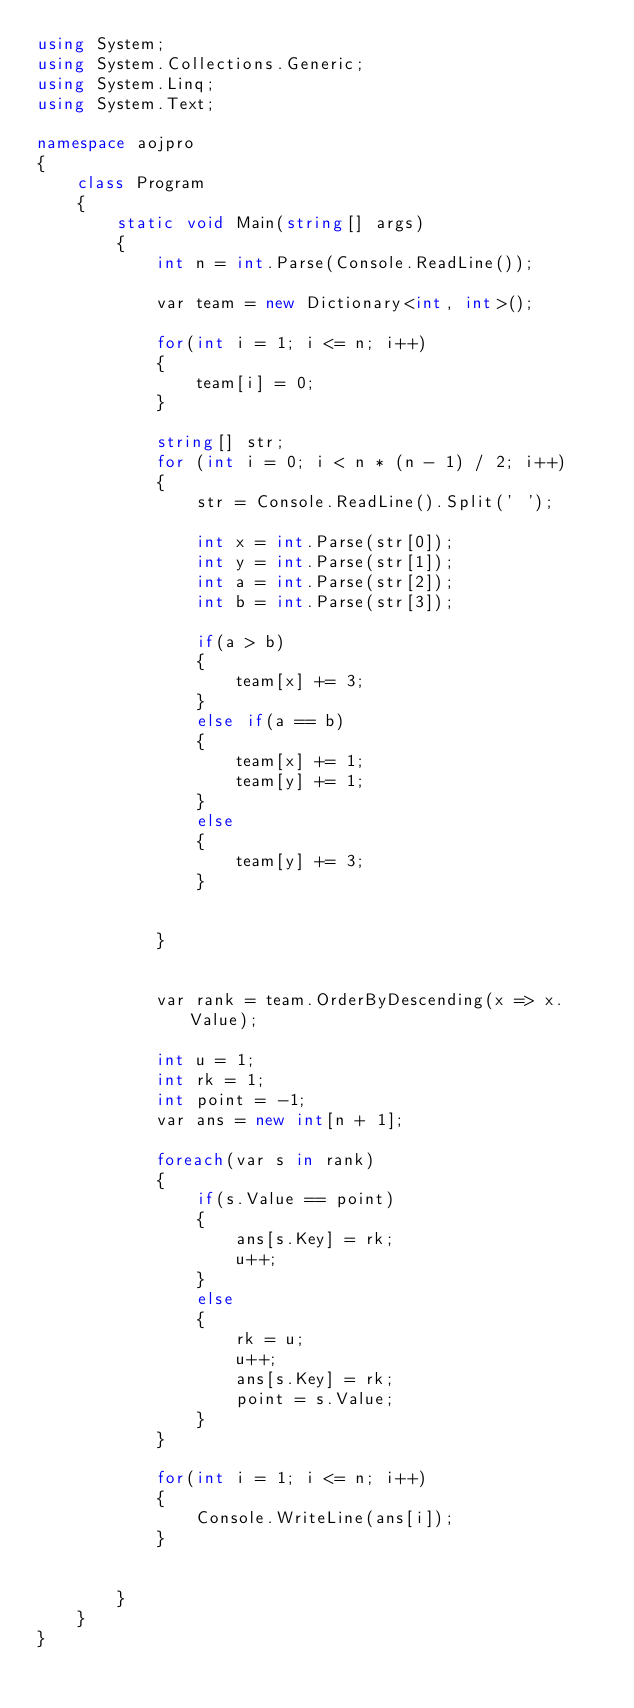Convert code to text. <code><loc_0><loc_0><loc_500><loc_500><_C#_>using System;
using System.Collections.Generic;
using System.Linq;
using System.Text;

namespace aojpro
{
    class Program
    {
        static void Main(string[] args)
        {
            int n = int.Parse(Console.ReadLine());

            var team = new Dictionary<int, int>();

            for(int i = 1; i <= n; i++)
            {
                team[i] = 0;
            }

            string[] str;
            for (int i = 0; i < n * (n - 1) / 2; i++)
            {
                str = Console.ReadLine().Split(' ');

                int x = int.Parse(str[0]);
                int y = int.Parse(str[1]);
                int a = int.Parse(str[2]);
                int b = int.Parse(str[3]);

                if(a > b)
                {
                    team[x] += 3;
                }
                else if(a == b)
                {
                    team[x] += 1;
                    team[y] += 1;
                }
                else
                {
                    team[y] += 3;
                }


            }            
            
            
            var rank = team.OrderByDescending(x => x.Value);            

            int u = 1;
            int rk = 1;
            int point = -1;
            var ans = new int[n + 1]; 

            foreach(var s in rank)
            {               
                if(s.Value == point)
                {
                    ans[s.Key] = rk;
                    u++;
                }
                else
                {
                    rk = u;
                    u++;
                    ans[s.Key] = rk;
                    point = s.Value;
                }
            }

            for(int i = 1; i <= n; i++)
            {
                Console.WriteLine(ans[i]);
            }


        }
    }
}

</code> 